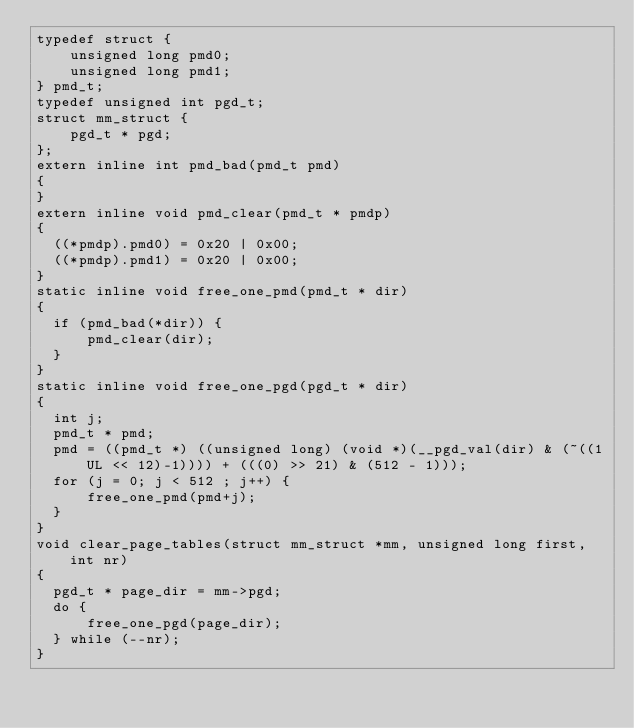<code> <loc_0><loc_0><loc_500><loc_500><_C_>typedef struct {
    unsigned long pmd0;
    unsigned long pmd1;
} pmd_t;
typedef unsigned int pgd_t;
struct mm_struct {
    pgd_t * pgd;
};
extern inline int pmd_bad(pmd_t pmd)
{
}
extern inline void pmd_clear(pmd_t * pmdp)
{
  ((*pmdp).pmd0) = 0x20 | 0x00;
  ((*pmdp).pmd1) = 0x20 | 0x00;
}
static inline void free_one_pmd(pmd_t * dir)
{
  if (pmd_bad(*dir)) {
      pmd_clear(dir);
  }
}
static inline void free_one_pgd(pgd_t * dir)
{
  int j;
  pmd_t * pmd;
  pmd = ((pmd_t *) ((unsigned long) (void *)(__pgd_val(dir) & (~((1UL << 12)-1)))) + (((0) >> 21) & (512 - 1)));
  for (j = 0; j < 512 ; j++) {
      free_one_pmd(pmd+j);
  }
}
void clear_page_tables(struct mm_struct *mm, unsigned long first, int nr)
{
  pgd_t * page_dir = mm->pgd;
  do {
      free_one_pgd(page_dir);
  } while (--nr);
}
</code> 